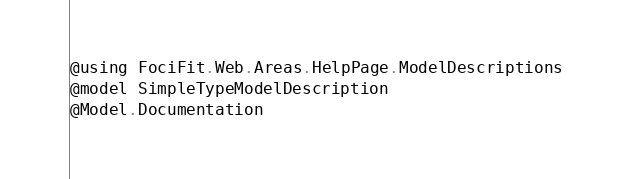Convert code to text. <code><loc_0><loc_0><loc_500><loc_500><_C#_>@using FociFit.Web.Areas.HelpPage.ModelDescriptions
@model SimpleTypeModelDescription
@Model.Documentation</code> 